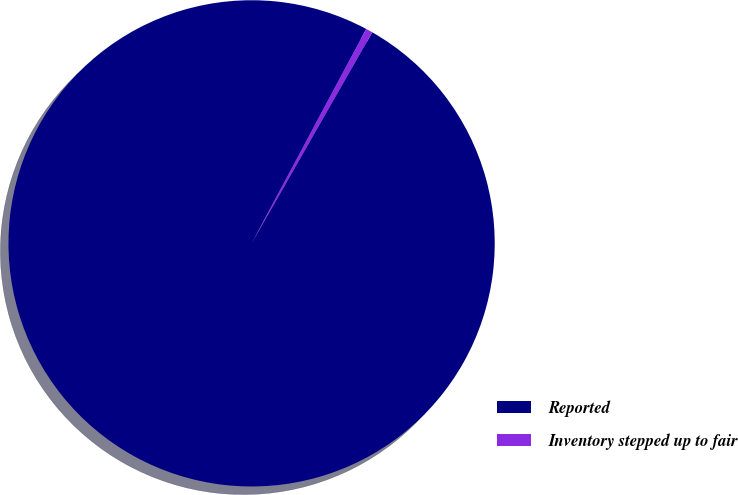Convert chart to OTSL. <chart><loc_0><loc_0><loc_500><loc_500><pie_chart><fcel>Reported<fcel>Inventory stepped up to fair<nl><fcel>99.55%<fcel>0.45%<nl></chart> 